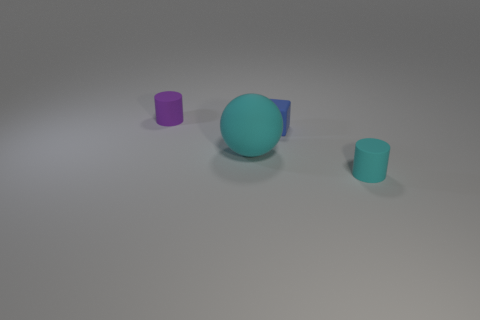Are the tiny cylinder that is right of the small purple matte thing and the blue cube made of the same material? yes 